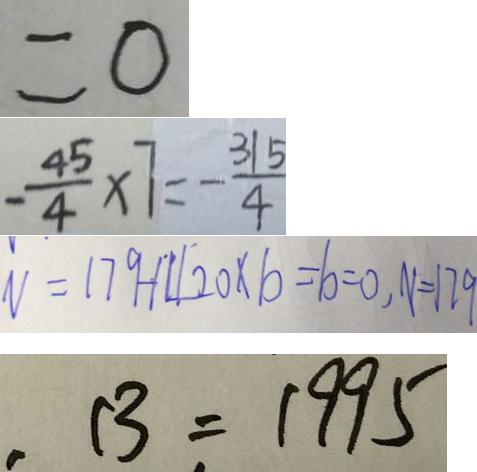Convert formula to latex. <formula><loc_0><loc_0><loc_500><loc_500>= 0 
 - \frac { 4 5 } { 4 } \times 7 = - \frac { 3 1 5 } { 4 } 
 V = 1 7 9 - 1 4 2 0 \times b = b = 0 , V = 1 7 9 
 , B = 1 9 9 5</formula> 